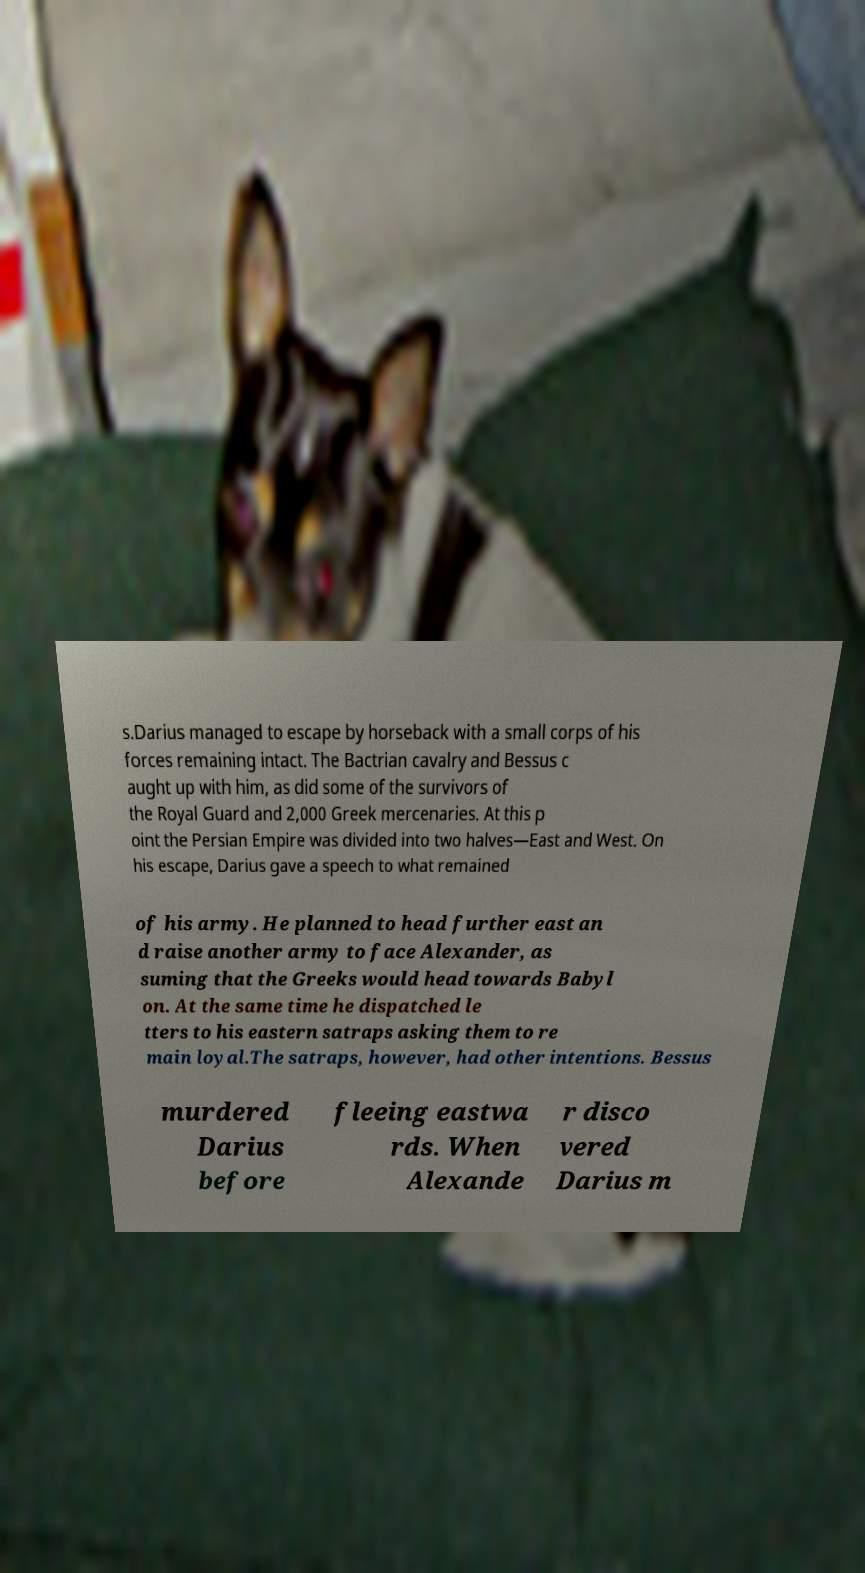What messages or text are displayed in this image? I need them in a readable, typed format. s.Darius managed to escape by horseback with a small corps of his forces remaining intact. The Bactrian cavalry and Bessus c aught up with him, as did some of the survivors of the Royal Guard and 2,000 Greek mercenaries. At this p oint the Persian Empire was divided into two halves—East and West. On his escape, Darius gave a speech to what remained of his army. He planned to head further east an d raise another army to face Alexander, as suming that the Greeks would head towards Babyl on. At the same time he dispatched le tters to his eastern satraps asking them to re main loyal.The satraps, however, had other intentions. Bessus murdered Darius before fleeing eastwa rds. When Alexande r disco vered Darius m 